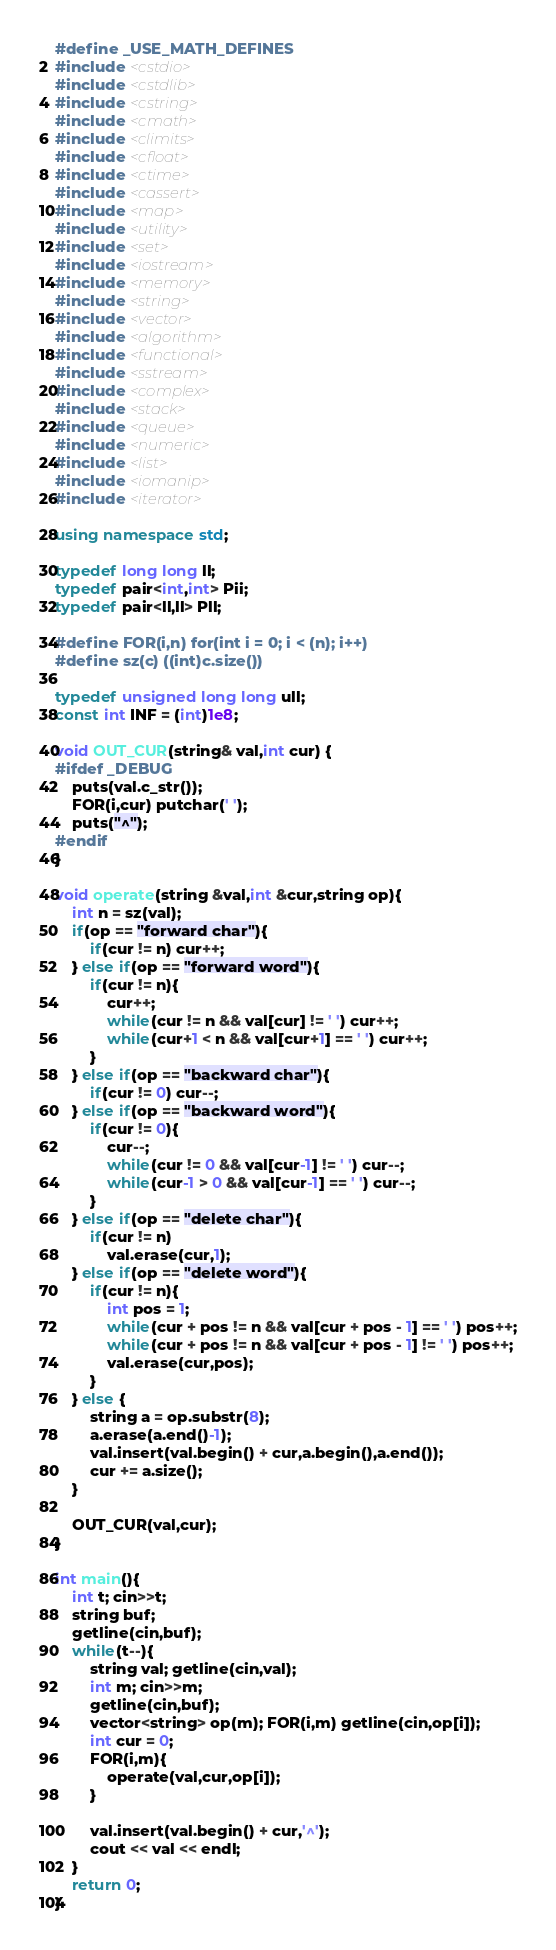Convert code to text. <code><loc_0><loc_0><loc_500><loc_500><_C++_>#define _USE_MATH_DEFINES
#include <cstdio>
#include <cstdlib>
#include <cstring>
#include <cmath>
#include <climits>
#include <cfloat>
#include <ctime>
#include <cassert>
#include <map>
#include <utility>
#include <set>
#include <iostream>
#include <memory>
#include <string>
#include <vector>
#include <algorithm>
#include <functional>
#include <sstream>
#include <complex>
#include <stack>
#include <queue>
#include <numeric>
#include <list>
#include <iomanip>
#include <iterator>
 
using namespace std;
 
typedef long long ll;
typedef pair<int,int> Pii;
typedef pair<ll,ll> Pll;
 
#define FOR(i,n) for(int i = 0; i < (n); i++)
#define sz(c) ((int)c.size())

typedef unsigned long long ull;
const int INF = (int)1e8;

void OUT_CUR(string& val,int cur) { 
#ifdef _DEBUG
	puts(val.c_str());
	FOR(i,cur) putchar(' ');
	puts("^");
#endif
}

void operate(string &val,int &cur,string op){
	int n = sz(val);
	if(op == "forward char"){
		if(cur != n) cur++;
	} else if(op == "forward word"){
		if(cur != n){
			cur++;
			while(cur != n && val[cur] != ' ') cur++; 
			while(cur+1 < n && val[cur+1] == ' ') cur++;
		}
	} else if(op == "backward char"){
		if(cur != 0) cur--;
	} else if(op == "backward word"){
		if(cur != 0){
			cur--;
			while(cur != 0 && val[cur-1] != ' ') cur--; 
			while(cur-1 > 0 && val[cur-1] == ' ') cur--; 
		}
	} else if(op == "delete char"){
		if(cur != n)
			val.erase(cur,1);
	} else if(op == "delete word"){
		if(cur != n){
			int pos = 1;
			while(cur + pos != n && val[cur + pos - 1] == ' ') pos++;
			while(cur + pos != n && val[cur + pos - 1] != ' ') pos++;
			val.erase(cur,pos);
		}
	} else {
		string a = op.substr(8);
		a.erase(a.end()-1);
		val.insert(val.begin() + cur,a.begin(),a.end());
		cur += a.size();
	}

	OUT_CUR(val,cur);
}

int main(){
	int t; cin>>t;
	string buf;
	getline(cin,buf);
	while(t--){
		string val; getline(cin,val);
		int m; cin>>m;
		getline(cin,buf);
		vector<string> op(m); FOR(i,m) getline(cin,op[i]);
		int cur = 0;
		FOR(i,m){
			operate(val,cur,op[i]);
		}

		val.insert(val.begin() + cur,'^');
		cout << val << endl; 
	}
	return 0;
}</code> 